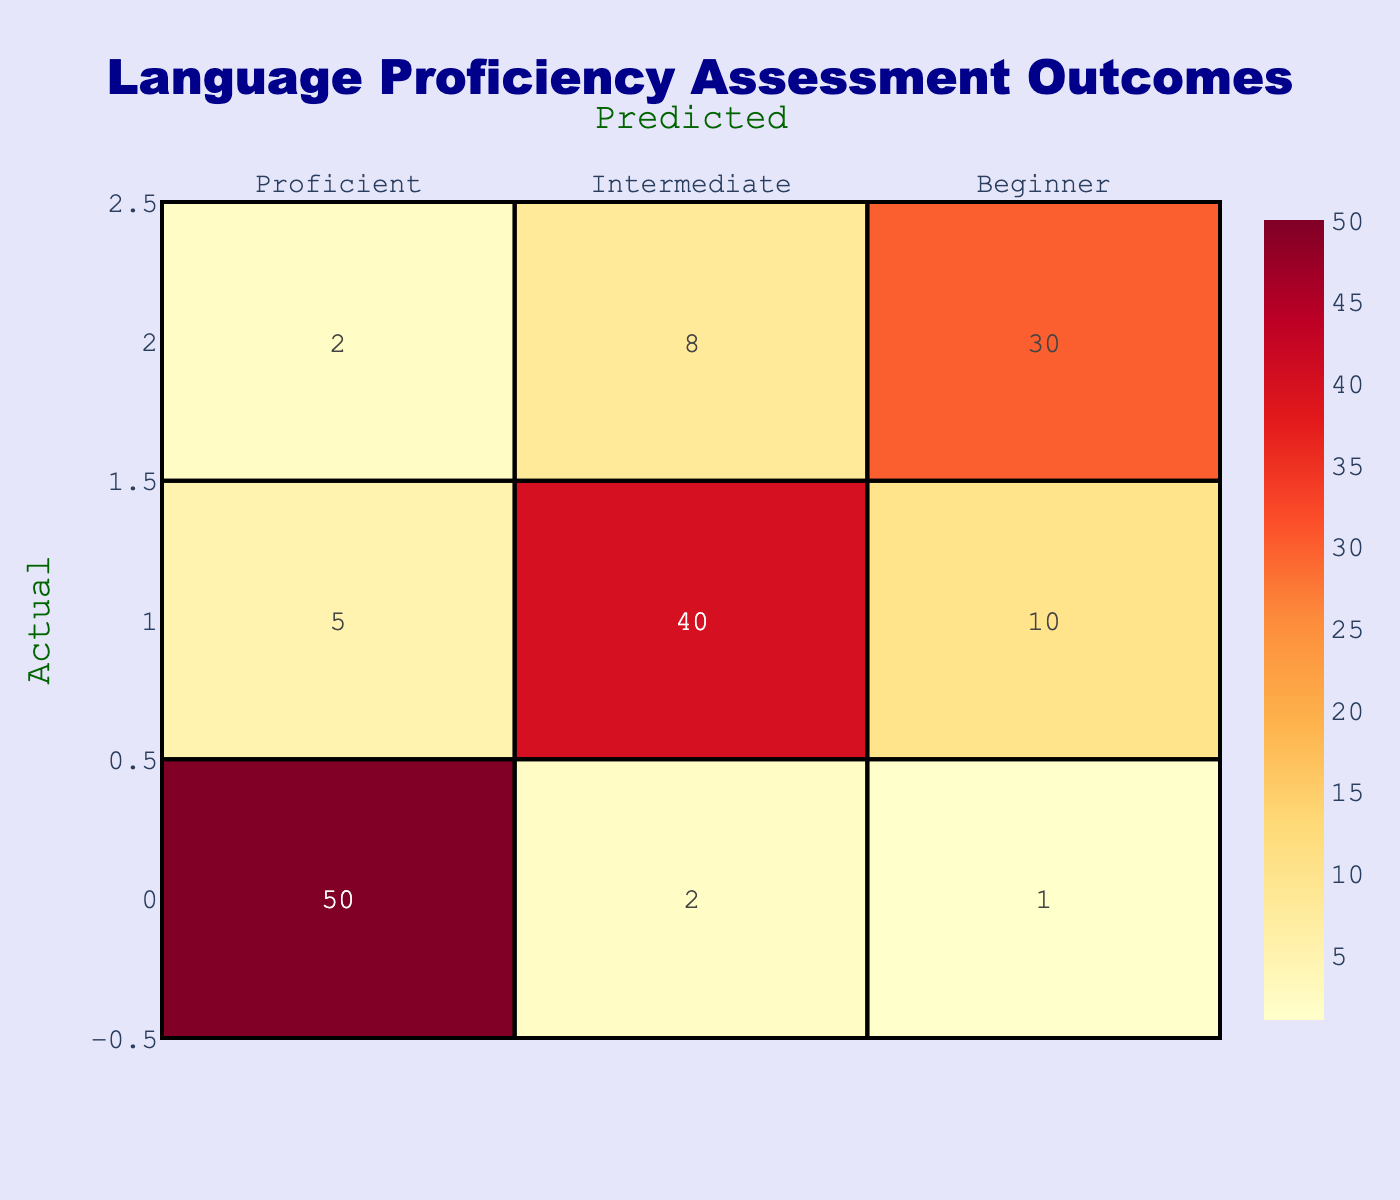What is the number of students who were actually proficient and predicted to be proficient? Looking at the designated cell where "Actual" is "Proficient" and "Predicted" is also "Proficient," we find the value is 50.
Answer: 50 What is the total number of students assessed at the "Beginner" level? To find this, we look at the "Beginner" row and sum all cells: 2 (Predicted Proficient) + 8 (Predicted Intermediate) + 30 (Predicted Beginner) = 40.
Answer: 40 Is the number of students predicted to be "Intermediate" higher than those predicted to be "Beginner"? We need to compare the totals for "Predicted Intermediate" (2 + 40 + 10 = 52) and "Predicted Beginner" (1 + 10 + 30 = 41). Since 52 is greater than 41, the answer is yes.
Answer: Yes What percentage of students who were actually "Intermediate" were predicted correctly? From the "Intermediate" row, the actual count of "Intermediate" is 40 (correct predictions). The total number in this row is 5 (Proficient) + 40 (Intermediate) + 10 (Beginner) = 55.  The percentage is (40/55)*100 = 72.73%.
Answer: 72.73% What is the difference in the number of students predicted as "Beginner" versus those predicted as "Proficient"? First, we sum up the prediction counts for each level. For "Beginner," this is 1 (from Proficient) + 10 (from Intermediate) + 30 (from Beginner), giving us 41. For "Proficient," the sum is 50 (from Proficient) + 5 (from Intermediate) + 2 (from Beginner), giving us 57. The difference is 57 - 41 = 16.
Answer: 16 How many more students were correctly predicted as "Proficient" compared to "Beginner"? The correct predictions for "Proficient" is 50 and for "Beginner," it is 30. The difference is 50 - 30 = 20, so 20 more students were correctly predicted as "Proficient."
Answer: 20 Are there more students overall categorized as "Intermediate" than those categorized as "Proficient"? We add the total number of students for "Proficient" (50 + 2 + 1 = 53) and "Intermediate" (5 + 40 + 10 = 55). Since 55 is greater than 53, the answer is yes.
Answer: Yes What is the total number of "Proficient" students across all actual categories? Looking at the "Proficient" column, we add up the values: 50 (Proficient) + 5 (Intermediate) + 2 (Beginner) = 57.
Answer: 57 What is the ratio of "Beginner" predictions to the total assessments? The "Beginner" predictions total 41 (1+10+30) while the overall total is 50 (Proficient) + 55 (Intermediate) + 40 (Beginner) = 145. The ratio is 41/145, which simplifies to approximately 0.28.
Answer: 0.28 